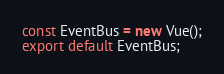Convert code to text. <code><loc_0><loc_0><loc_500><loc_500><_JavaScript_>const EventBus = new Vue();
export default EventBus;</code> 